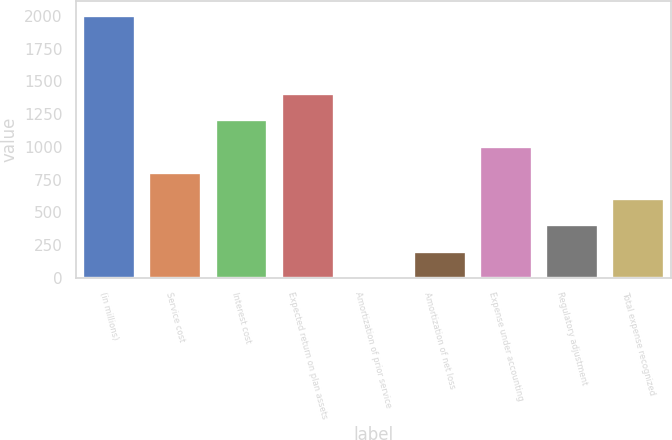<chart> <loc_0><loc_0><loc_500><loc_500><bar_chart><fcel>(in millions)<fcel>Service cost<fcel>Interest cost<fcel>Expected return on plan assets<fcel>Amortization of prior service<fcel>Amortization of net loss<fcel>Expense under accounting<fcel>Regulatory adjustment<fcel>Total expense recognized<nl><fcel>2010<fcel>808.8<fcel>1209.2<fcel>1409.4<fcel>8<fcel>208.2<fcel>1009<fcel>408.4<fcel>608.6<nl></chart> 